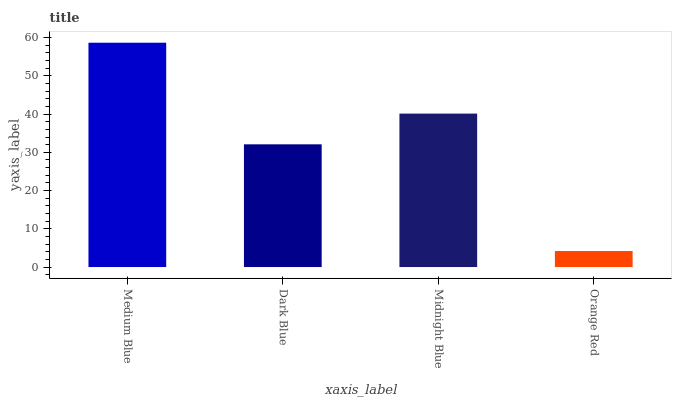Is Orange Red the minimum?
Answer yes or no. Yes. Is Medium Blue the maximum?
Answer yes or no. Yes. Is Dark Blue the minimum?
Answer yes or no. No. Is Dark Blue the maximum?
Answer yes or no. No. Is Medium Blue greater than Dark Blue?
Answer yes or no. Yes. Is Dark Blue less than Medium Blue?
Answer yes or no. Yes. Is Dark Blue greater than Medium Blue?
Answer yes or no. No. Is Medium Blue less than Dark Blue?
Answer yes or no. No. Is Midnight Blue the high median?
Answer yes or no. Yes. Is Dark Blue the low median?
Answer yes or no. Yes. Is Orange Red the high median?
Answer yes or no. No. Is Medium Blue the low median?
Answer yes or no. No. 